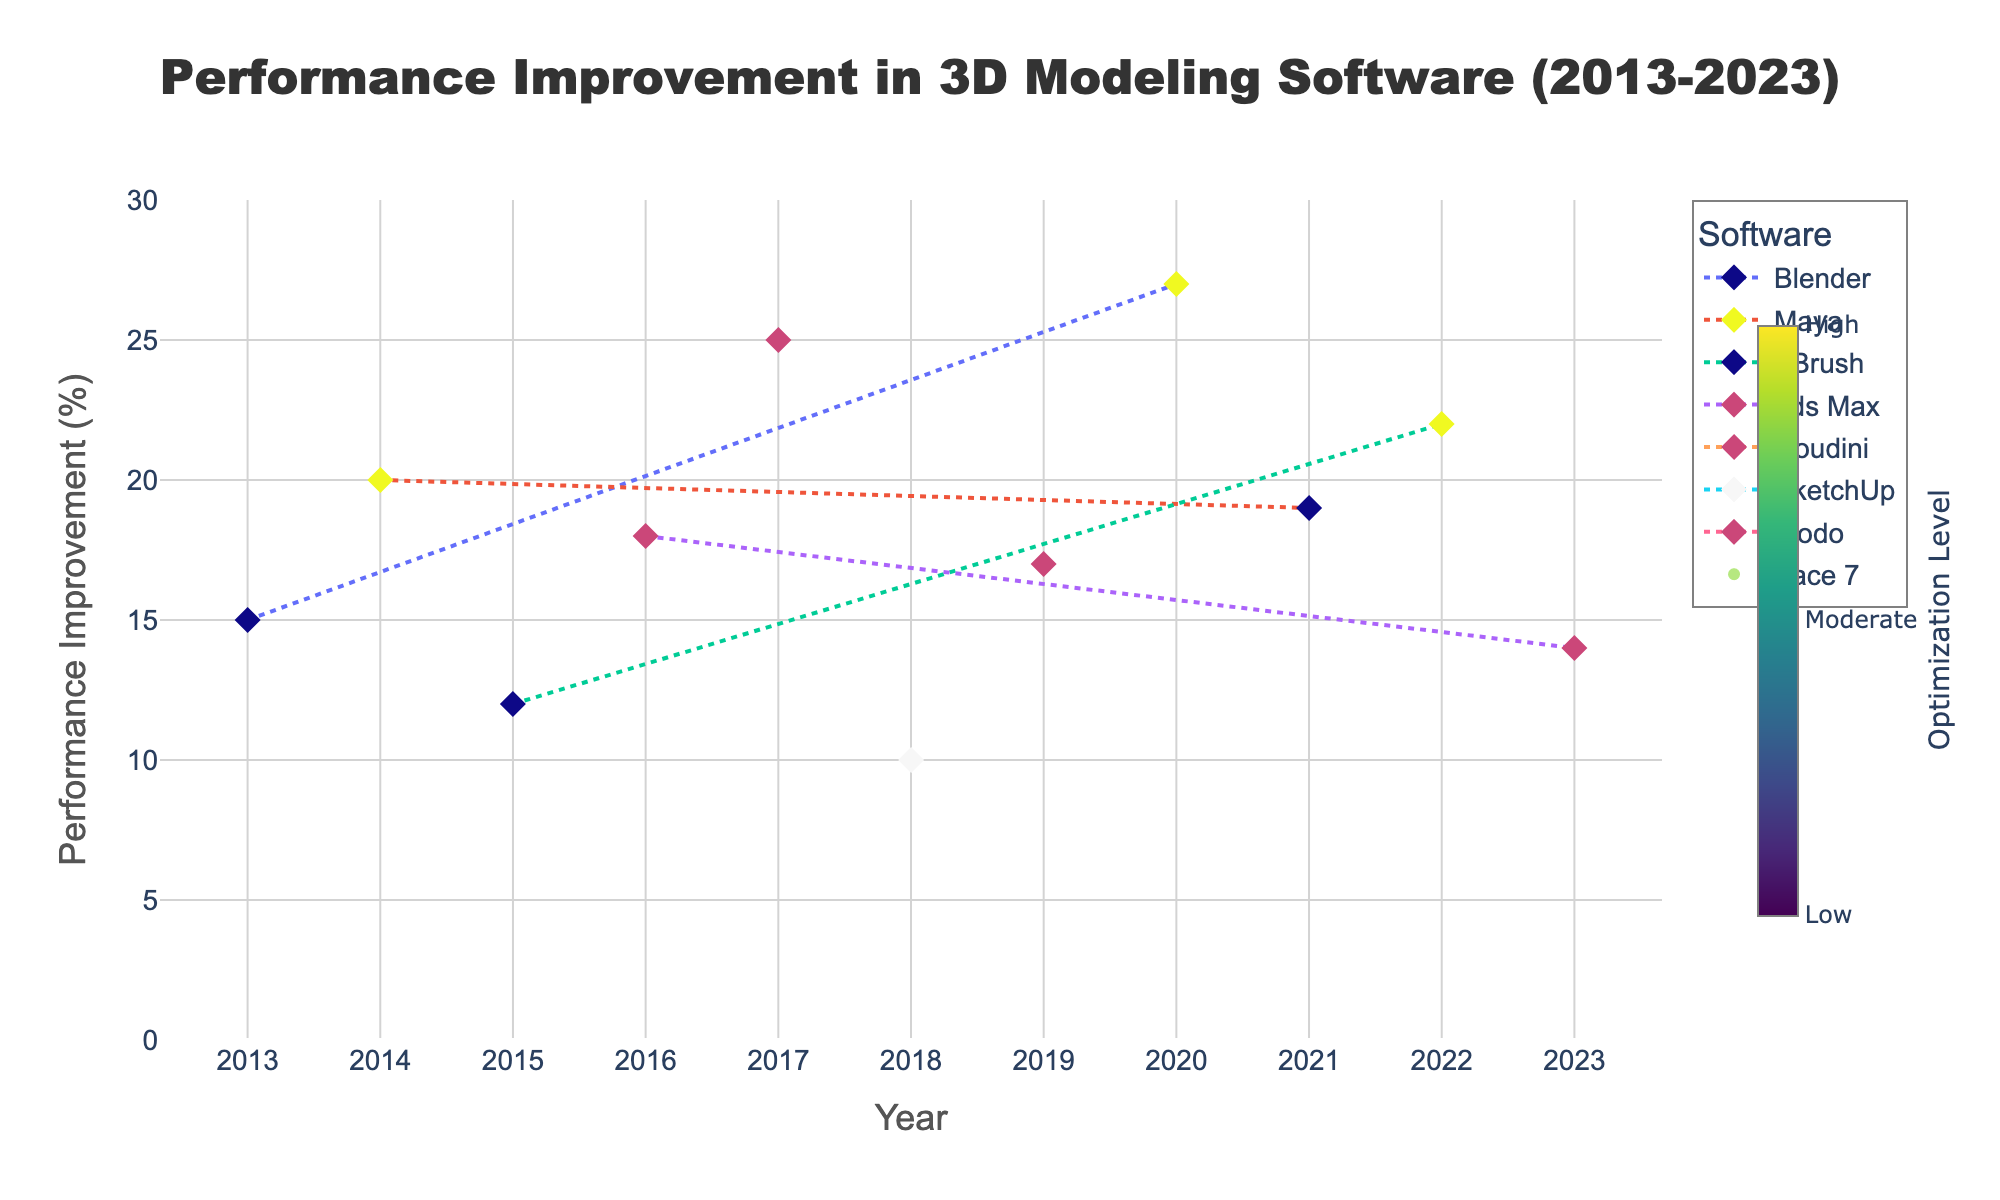What is the title of the figure? The title is displayed prominently at the top of the figure, typically in larger font. It reads 'Performance Improvement in 3D Modeling Software (2013-2023)'.
Answer: Performance Improvement in 3D Modeling Software (2013-2023) Which software showed the highest performance improvement? To determine this, we look at the peak y-values on the time series plot. The highest improvement value is 27%, associated with Blender in 2020.
Answer: Blender How many unique algorithms are depicted in the figure? Each point on the plot corresponds to a unique algorithm, identified by the hover text. Counting the unique algorithms, we see ten different algorithms.
Answer: 10 Between which years did Maya see the highest increase in performance improvement? For Maya, we look at the years this software is plotted and note the performance improvements for these years. The highest increase is from 2014 to 2021, going from 20% to 19%. Comparing these, we get the highest increase from 2014 (20%) to 2021 (19%).
Answer: 2014-2021 Which optimization level is represented by the most occurrences? By observing the color bar and markers' fill color, we count the occurrences of Low, Moderate, and High optimization levels across all points. Moderate appears most frequently.
Answer: Moderate Which algorithm was used by ZBrush in 2022? Clicking or hovering over the data point for 2022 with ZBrush shows the algorithm name. It was the Genetic Algorithm.
Answer: Genetic Algorithm Compare the performance improvement of Blender in 2013 with Blender in 2020. We check the y-values for Blender in 2013 (15%) and 2020 (27%). Subtracting these gives the performance improvement difference, which is 27 - 15 = 12.
Answer: 12% What trend can be observed in the performance improvement of 3ds Max from 2016 to 2023? Observing the performance improvement values for 3ds Max from 2016 to 2023, we see values at 2016 (18%) and 2023 (14%). The trend indicates a slight decrease over these years.
Answer: Decreasing Which year had the lowest performance improvement for SketchUp? Checking the performance improvement values for SketchUp, we find the lowest value in 2018 with 10%.
Answer: 2018 